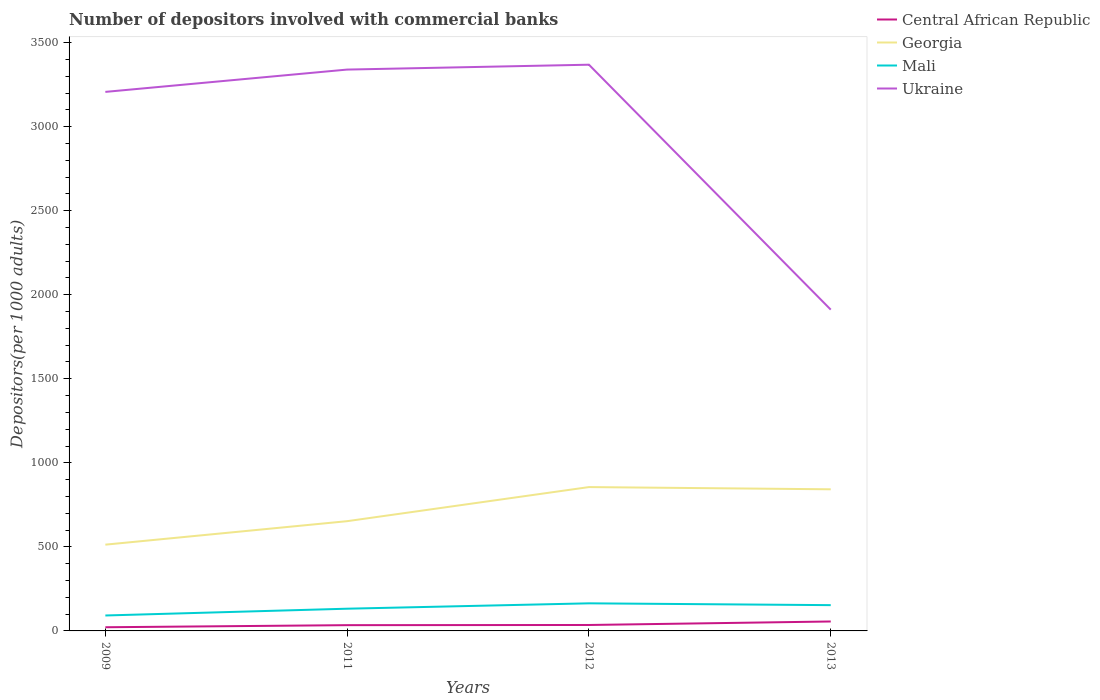How many different coloured lines are there?
Give a very brief answer. 4. Is the number of lines equal to the number of legend labels?
Your answer should be compact. Yes. Across all years, what is the maximum number of depositors involved with commercial banks in Central African Republic?
Your response must be concise. 21.85. What is the total number of depositors involved with commercial banks in Central African Republic in the graph?
Make the answer very short. -20.82. What is the difference between the highest and the second highest number of depositors involved with commercial banks in Georgia?
Provide a succinct answer. 342.55. What is the difference between the highest and the lowest number of depositors involved with commercial banks in Ukraine?
Ensure brevity in your answer.  3. Is the number of depositors involved with commercial banks in Georgia strictly greater than the number of depositors involved with commercial banks in Central African Republic over the years?
Your answer should be very brief. No. What is the difference between two consecutive major ticks on the Y-axis?
Your answer should be very brief. 500. Are the values on the major ticks of Y-axis written in scientific E-notation?
Provide a short and direct response. No. Does the graph contain any zero values?
Keep it short and to the point. No. How are the legend labels stacked?
Make the answer very short. Vertical. What is the title of the graph?
Keep it short and to the point. Number of depositors involved with commercial banks. What is the label or title of the Y-axis?
Ensure brevity in your answer.  Depositors(per 1000 adults). What is the Depositors(per 1000 adults) of Central African Republic in 2009?
Your answer should be compact. 21.85. What is the Depositors(per 1000 adults) of Georgia in 2009?
Give a very brief answer. 513.17. What is the Depositors(per 1000 adults) of Mali in 2009?
Make the answer very short. 91.79. What is the Depositors(per 1000 adults) in Ukraine in 2009?
Offer a terse response. 3206.64. What is the Depositors(per 1000 adults) in Central African Republic in 2011?
Provide a short and direct response. 34.26. What is the Depositors(per 1000 adults) in Georgia in 2011?
Provide a short and direct response. 652.89. What is the Depositors(per 1000 adults) in Mali in 2011?
Ensure brevity in your answer.  132.15. What is the Depositors(per 1000 adults) in Ukraine in 2011?
Provide a succinct answer. 3339.41. What is the Depositors(per 1000 adults) in Central African Republic in 2012?
Provide a succinct answer. 35.28. What is the Depositors(per 1000 adults) in Georgia in 2012?
Provide a succinct answer. 855.71. What is the Depositors(per 1000 adults) in Mali in 2012?
Provide a short and direct response. 164.15. What is the Depositors(per 1000 adults) of Ukraine in 2012?
Your answer should be very brief. 3368.39. What is the Depositors(per 1000 adults) of Central African Republic in 2013?
Offer a very short reply. 56.1. What is the Depositors(per 1000 adults) in Georgia in 2013?
Keep it short and to the point. 842.51. What is the Depositors(per 1000 adults) in Mali in 2013?
Your answer should be very brief. 153.37. What is the Depositors(per 1000 adults) of Ukraine in 2013?
Give a very brief answer. 1911.24. Across all years, what is the maximum Depositors(per 1000 adults) of Central African Republic?
Give a very brief answer. 56.1. Across all years, what is the maximum Depositors(per 1000 adults) of Georgia?
Provide a short and direct response. 855.71. Across all years, what is the maximum Depositors(per 1000 adults) in Mali?
Offer a terse response. 164.15. Across all years, what is the maximum Depositors(per 1000 adults) of Ukraine?
Your answer should be compact. 3368.39. Across all years, what is the minimum Depositors(per 1000 adults) in Central African Republic?
Your response must be concise. 21.85. Across all years, what is the minimum Depositors(per 1000 adults) of Georgia?
Your answer should be compact. 513.17. Across all years, what is the minimum Depositors(per 1000 adults) of Mali?
Provide a succinct answer. 91.79. Across all years, what is the minimum Depositors(per 1000 adults) in Ukraine?
Provide a succinct answer. 1911.24. What is the total Depositors(per 1000 adults) of Central African Republic in the graph?
Offer a terse response. 147.48. What is the total Depositors(per 1000 adults) in Georgia in the graph?
Your answer should be compact. 2864.28. What is the total Depositors(per 1000 adults) in Mali in the graph?
Make the answer very short. 541.47. What is the total Depositors(per 1000 adults) in Ukraine in the graph?
Your answer should be compact. 1.18e+04. What is the difference between the Depositors(per 1000 adults) in Central African Republic in 2009 and that in 2011?
Provide a succinct answer. -12.4. What is the difference between the Depositors(per 1000 adults) of Georgia in 2009 and that in 2011?
Offer a terse response. -139.72. What is the difference between the Depositors(per 1000 adults) of Mali in 2009 and that in 2011?
Keep it short and to the point. -40.36. What is the difference between the Depositors(per 1000 adults) of Ukraine in 2009 and that in 2011?
Offer a terse response. -132.77. What is the difference between the Depositors(per 1000 adults) of Central African Republic in 2009 and that in 2012?
Make the answer very short. -13.43. What is the difference between the Depositors(per 1000 adults) in Georgia in 2009 and that in 2012?
Offer a terse response. -342.55. What is the difference between the Depositors(per 1000 adults) of Mali in 2009 and that in 2012?
Offer a very short reply. -72.36. What is the difference between the Depositors(per 1000 adults) of Ukraine in 2009 and that in 2012?
Ensure brevity in your answer.  -161.75. What is the difference between the Depositors(per 1000 adults) in Central African Republic in 2009 and that in 2013?
Offer a terse response. -34.25. What is the difference between the Depositors(per 1000 adults) in Georgia in 2009 and that in 2013?
Provide a succinct answer. -329.35. What is the difference between the Depositors(per 1000 adults) in Mali in 2009 and that in 2013?
Offer a very short reply. -61.58. What is the difference between the Depositors(per 1000 adults) in Ukraine in 2009 and that in 2013?
Give a very brief answer. 1295.4. What is the difference between the Depositors(per 1000 adults) in Central African Republic in 2011 and that in 2012?
Keep it short and to the point. -1.02. What is the difference between the Depositors(per 1000 adults) in Georgia in 2011 and that in 2012?
Provide a succinct answer. -202.83. What is the difference between the Depositors(per 1000 adults) in Mali in 2011 and that in 2012?
Make the answer very short. -32. What is the difference between the Depositors(per 1000 adults) of Ukraine in 2011 and that in 2012?
Your answer should be compact. -28.98. What is the difference between the Depositors(per 1000 adults) in Central African Republic in 2011 and that in 2013?
Give a very brief answer. -21.84. What is the difference between the Depositors(per 1000 adults) in Georgia in 2011 and that in 2013?
Provide a short and direct response. -189.63. What is the difference between the Depositors(per 1000 adults) in Mali in 2011 and that in 2013?
Ensure brevity in your answer.  -21.22. What is the difference between the Depositors(per 1000 adults) of Ukraine in 2011 and that in 2013?
Offer a very short reply. 1428.17. What is the difference between the Depositors(per 1000 adults) in Central African Republic in 2012 and that in 2013?
Your answer should be very brief. -20.82. What is the difference between the Depositors(per 1000 adults) of Georgia in 2012 and that in 2013?
Your response must be concise. 13.2. What is the difference between the Depositors(per 1000 adults) of Mali in 2012 and that in 2013?
Your answer should be compact. 10.78. What is the difference between the Depositors(per 1000 adults) of Ukraine in 2012 and that in 2013?
Ensure brevity in your answer.  1457.15. What is the difference between the Depositors(per 1000 adults) in Central African Republic in 2009 and the Depositors(per 1000 adults) in Georgia in 2011?
Ensure brevity in your answer.  -631.04. What is the difference between the Depositors(per 1000 adults) of Central African Republic in 2009 and the Depositors(per 1000 adults) of Mali in 2011?
Your answer should be compact. -110.3. What is the difference between the Depositors(per 1000 adults) of Central African Republic in 2009 and the Depositors(per 1000 adults) of Ukraine in 2011?
Make the answer very short. -3317.56. What is the difference between the Depositors(per 1000 adults) in Georgia in 2009 and the Depositors(per 1000 adults) in Mali in 2011?
Your answer should be very brief. 381.01. What is the difference between the Depositors(per 1000 adults) of Georgia in 2009 and the Depositors(per 1000 adults) of Ukraine in 2011?
Your response must be concise. -2826.24. What is the difference between the Depositors(per 1000 adults) of Mali in 2009 and the Depositors(per 1000 adults) of Ukraine in 2011?
Make the answer very short. -3247.61. What is the difference between the Depositors(per 1000 adults) in Central African Republic in 2009 and the Depositors(per 1000 adults) in Georgia in 2012?
Provide a short and direct response. -833.86. What is the difference between the Depositors(per 1000 adults) in Central African Republic in 2009 and the Depositors(per 1000 adults) in Mali in 2012?
Your answer should be compact. -142.3. What is the difference between the Depositors(per 1000 adults) of Central African Republic in 2009 and the Depositors(per 1000 adults) of Ukraine in 2012?
Provide a short and direct response. -3346.54. What is the difference between the Depositors(per 1000 adults) in Georgia in 2009 and the Depositors(per 1000 adults) in Mali in 2012?
Ensure brevity in your answer.  349.01. What is the difference between the Depositors(per 1000 adults) in Georgia in 2009 and the Depositors(per 1000 adults) in Ukraine in 2012?
Provide a short and direct response. -2855.22. What is the difference between the Depositors(per 1000 adults) in Mali in 2009 and the Depositors(per 1000 adults) in Ukraine in 2012?
Ensure brevity in your answer.  -3276.59. What is the difference between the Depositors(per 1000 adults) of Central African Republic in 2009 and the Depositors(per 1000 adults) of Georgia in 2013?
Offer a terse response. -820.66. What is the difference between the Depositors(per 1000 adults) of Central African Republic in 2009 and the Depositors(per 1000 adults) of Mali in 2013?
Make the answer very short. -131.52. What is the difference between the Depositors(per 1000 adults) of Central African Republic in 2009 and the Depositors(per 1000 adults) of Ukraine in 2013?
Give a very brief answer. -1889.38. What is the difference between the Depositors(per 1000 adults) in Georgia in 2009 and the Depositors(per 1000 adults) in Mali in 2013?
Your answer should be very brief. 359.79. What is the difference between the Depositors(per 1000 adults) of Georgia in 2009 and the Depositors(per 1000 adults) of Ukraine in 2013?
Offer a terse response. -1398.07. What is the difference between the Depositors(per 1000 adults) in Mali in 2009 and the Depositors(per 1000 adults) in Ukraine in 2013?
Provide a succinct answer. -1819.44. What is the difference between the Depositors(per 1000 adults) in Central African Republic in 2011 and the Depositors(per 1000 adults) in Georgia in 2012?
Provide a short and direct response. -821.46. What is the difference between the Depositors(per 1000 adults) of Central African Republic in 2011 and the Depositors(per 1000 adults) of Mali in 2012?
Make the answer very short. -129.9. What is the difference between the Depositors(per 1000 adults) of Central African Republic in 2011 and the Depositors(per 1000 adults) of Ukraine in 2012?
Your response must be concise. -3334.13. What is the difference between the Depositors(per 1000 adults) in Georgia in 2011 and the Depositors(per 1000 adults) in Mali in 2012?
Offer a very short reply. 488.73. What is the difference between the Depositors(per 1000 adults) in Georgia in 2011 and the Depositors(per 1000 adults) in Ukraine in 2012?
Your answer should be compact. -2715.5. What is the difference between the Depositors(per 1000 adults) of Mali in 2011 and the Depositors(per 1000 adults) of Ukraine in 2012?
Your response must be concise. -3236.23. What is the difference between the Depositors(per 1000 adults) of Central African Republic in 2011 and the Depositors(per 1000 adults) of Georgia in 2013?
Provide a succinct answer. -808.26. What is the difference between the Depositors(per 1000 adults) in Central African Republic in 2011 and the Depositors(per 1000 adults) in Mali in 2013?
Ensure brevity in your answer.  -119.12. What is the difference between the Depositors(per 1000 adults) of Central African Republic in 2011 and the Depositors(per 1000 adults) of Ukraine in 2013?
Your answer should be very brief. -1876.98. What is the difference between the Depositors(per 1000 adults) in Georgia in 2011 and the Depositors(per 1000 adults) in Mali in 2013?
Keep it short and to the point. 499.51. What is the difference between the Depositors(per 1000 adults) of Georgia in 2011 and the Depositors(per 1000 adults) of Ukraine in 2013?
Your answer should be very brief. -1258.35. What is the difference between the Depositors(per 1000 adults) of Mali in 2011 and the Depositors(per 1000 adults) of Ukraine in 2013?
Your answer should be compact. -1779.08. What is the difference between the Depositors(per 1000 adults) in Central African Republic in 2012 and the Depositors(per 1000 adults) in Georgia in 2013?
Give a very brief answer. -807.23. What is the difference between the Depositors(per 1000 adults) of Central African Republic in 2012 and the Depositors(per 1000 adults) of Mali in 2013?
Keep it short and to the point. -118.09. What is the difference between the Depositors(per 1000 adults) in Central African Republic in 2012 and the Depositors(per 1000 adults) in Ukraine in 2013?
Offer a terse response. -1875.96. What is the difference between the Depositors(per 1000 adults) of Georgia in 2012 and the Depositors(per 1000 adults) of Mali in 2013?
Make the answer very short. 702.34. What is the difference between the Depositors(per 1000 adults) of Georgia in 2012 and the Depositors(per 1000 adults) of Ukraine in 2013?
Ensure brevity in your answer.  -1055.52. What is the difference between the Depositors(per 1000 adults) of Mali in 2012 and the Depositors(per 1000 adults) of Ukraine in 2013?
Give a very brief answer. -1747.08. What is the average Depositors(per 1000 adults) in Central African Republic per year?
Give a very brief answer. 36.87. What is the average Depositors(per 1000 adults) in Georgia per year?
Give a very brief answer. 716.07. What is the average Depositors(per 1000 adults) in Mali per year?
Offer a terse response. 135.37. What is the average Depositors(per 1000 adults) in Ukraine per year?
Your answer should be very brief. 2956.42. In the year 2009, what is the difference between the Depositors(per 1000 adults) of Central African Republic and Depositors(per 1000 adults) of Georgia?
Make the answer very short. -491.31. In the year 2009, what is the difference between the Depositors(per 1000 adults) in Central African Republic and Depositors(per 1000 adults) in Mali?
Your response must be concise. -69.94. In the year 2009, what is the difference between the Depositors(per 1000 adults) in Central African Republic and Depositors(per 1000 adults) in Ukraine?
Provide a succinct answer. -3184.79. In the year 2009, what is the difference between the Depositors(per 1000 adults) in Georgia and Depositors(per 1000 adults) in Mali?
Your answer should be very brief. 421.37. In the year 2009, what is the difference between the Depositors(per 1000 adults) of Georgia and Depositors(per 1000 adults) of Ukraine?
Give a very brief answer. -2693.47. In the year 2009, what is the difference between the Depositors(per 1000 adults) of Mali and Depositors(per 1000 adults) of Ukraine?
Provide a short and direct response. -3114.84. In the year 2011, what is the difference between the Depositors(per 1000 adults) in Central African Republic and Depositors(per 1000 adults) in Georgia?
Provide a succinct answer. -618.63. In the year 2011, what is the difference between the Depositors(per 1000 adults) of Central African Republic and Depositors(per 1000 adults) of Mali?
Make the answer very short. -97.9. In the year 2011, what is the difference between the Depositors(per 1000 adults) in Central African Republic and Depositors(per 1000 adults) in Ukraine?
Ensure brevity in your answer.  -3305.15. In the year 2011, what is the difference between the Depositors(per 1000 adults) in Georgia and Depositors(per 1000 adults) in Mali?
Your answer should be very brief. 520.73. In the year 2011, what is the difference between the Depositors(per 1000 adults) of Georgia and Depositors(per 1000 adults) of Ukraine?
Provide a succinct answer. -2686.52. In the year 2011, what is the difference between the Depositors(per 1000 adults) in Mali and Depositors(per 1000 adults) in Ukraine?
Offer a very short reply. -3207.25. In the year 2012, what is the difference between the Depositors(per 1000 adults) of Central African Republic and Depositors(per 1000 adults) of Georgia?
Provide a short and direct response. -820.43. In the year 2012, what is the difference between the Depositors(per 1000 adults) of Central African Republic and Depositors(per 1000 adults) of Mali?
Offer a terse response. -128.87. In the year 2012, what is the difference between the Depositors(per 1000 adults) in Central African Republic and Depositors(per 1000 adults) in Ukraine?
Make the answer very short. -3333.11. In the year 2012, what is the difference between the Depositors(per 1000 adults) of Georgia and Depositors(per 1000 adults) of Mali?
Offer a terse response. 691.56. In the year 2012, what is the difference between the Depositors(per 1000 adults) in Georgia and Depositors(per 1000 adults) in Ukraine?
Provide a short and direct response. -2512.67. In the year 2012, what is the difference between the Depositors(per 1000 adults) of Mali and Depositors(per 1000 adults) of Ukraine?
Your response must be concise. -3204.23. In the year 2013, what is the difference between the Depositors(per 1000 adults) in Central African Republic and Depositors(per 1000 adults) in Georgia?
Ensure brevity in your answer.  -786.41. In the year 2013, what is the difference between the Depositors(per 1000 adults) of Central African Republic and Depositors(per 1000 adults) of Mali?
Your answer should be compact. -97.27. In the year 2013, what is the difference between the Depositors(per 1000 adults) in Central African Republic and Depositors(per 1000 adults) in Ukraine?
Your answer should be very brief. -1855.14. In the year 2013, what is the difference between the Depositors(per 1000 adults) of Georgia and Depositors(per 1000 adults) of Mali?
Your answer should be very brief. 689.14. In the year 2013, what is the difference between the Depositors(per 1000 adults) of Georgia and Depositors(per 1000 adults) of Ukraine?
Give a very brief answer. -1068.72. In the year 2013, what is the difference between the Depositors(per 1000 adults) in Mali and Depositors(per 1000 adults) in Ukraine?
Your answer should be very brief. -1757.86. What is the ratio of the Depositors(per 1000 adults) of Central African Republic in 2009 to that in 2011?
Provide a short and direct response. 0.64. What is the ratio of the Depositors(per 1000 adults) of Georgia in 2009 to that in 2011?
Provide a succinct answer. 0.79. What is the ratio of the Depositors(per 1000 adults) of Mali in 2009 to that in 2011?
Offer a terse response. 0.69. What is the ratio of the Depositors(per 1000 adults) in Ukraine in 2009 to that in 2011?
Keep it short and to the point. 0.96. What is the ratio of the Depositors(per 1000 adults) of Central African Republic in 2009 to that in 2012?
Make the answer very short. 0.62. What is the ratio of the Depositors(per 1000 adults) of Georgia in 2009 to that in 2012?
Offer a terse response. 0.6. What is the ratio of the Depositors(per 1000 adults) in Mali in 2009 to that in 2012?
Keep it short and to the point. 0.56. What is the ratio of the Depositors(per 1000 adults) of Central African Republic in 2009 to that in 2013?
Provide a succinct answer. 0.39. What is the ratio of the Depositors(per 1000 adults) in Georgia in 2009 to that in 2013?
Make the answer very short. 0.61. What is the ratio of the Depositors(per 1000 adults) of Mali in 2009 to that in 2013?
Give a very brief answer. 0.6. What is the ratio of the Depositors(per 1000 adults) of Ukraine in 2009 to that in 2013?
Your answer should be compact. 1.68. What is the ratio of the Depositors(per 1000 adults) in Georgia in 2011 to that in 2012?
Your answer should be very brief. 0.76. What is the ratio of the Depositors(per 1000 adults) in Mali in 2011 to that in 2012?
Offer a very short reply. 0.81. What is the ratio of the Depositors(per 1000 adults) of Central African Republic in 2011 to that in 2013?
Provide a succinct answer. 0.61. What is the ratio of the Depositors(per 1000 adults) in Georgia in 2011 to that in 2013?
Provide a succinct answer. 0.77. What is the ratio of the Depositors(per 1000 adults) in Mali in 2011 to that in 2013?
Ensure brevity in your answer.  0.86. What is the ratio of the Depositors(per 1000 adults) of Ukraine in 2011 to that in 2013?
Your answer should be compact. 1.75. What is the ratio of the Depositors(per 1000 adults) of Central African Republic in 2012 to that in 2013?
Give a very brief answer. 0.63. What is the ratio of the Depositors(per 1000 adults) of Georgia in 2012 to that in 2013?
Offer a very short reply. 1.02. What is the ratio of the Depositors(per 1000 adults) in Mali in 2012 to that in 2013?
Give a very brief answer. 1.07. What is the ratio of the Depositors(per 1000 adults) in Ukraine in 2012 to that in 2013?
Offer a terse response. 1.76. What is the difference between the highest and the second highest Depositors(per 1000 adults) in Central African Republic?
Give a very brief answer. 20.82. What is the difference between the highest and the second highest Depositors(per 1000 adults) of Georgia?
Provide a succinct answer. 13.2. What is the difference between the highest and the second highest Depositors(per 1000 adults) in Mali?
Keep it short and to the point. 10.78. What is the difference between the highest and the second highest Depositors(per 1000 adults) in Ukraine?
Make the answer very short. 28.98. What is the difference between the highest and the lowest Depositors(per 1000 adults) in Central African Republic?
Your answer should be very brief. 34.25. What is the difference between the highest and the lowest Depositors(per 1000 adults) in Georgia?
Your answer should be compact. 342.55. What is the difference between the highest and the lowest Depositors(per 1000 adults) in Mali?
Provide a short and direct response. 72.36. What is the difference between the highest and the lowest Depositors(per 1000 adults) of Ukraine?
Your response must be concise. 1457.15. 